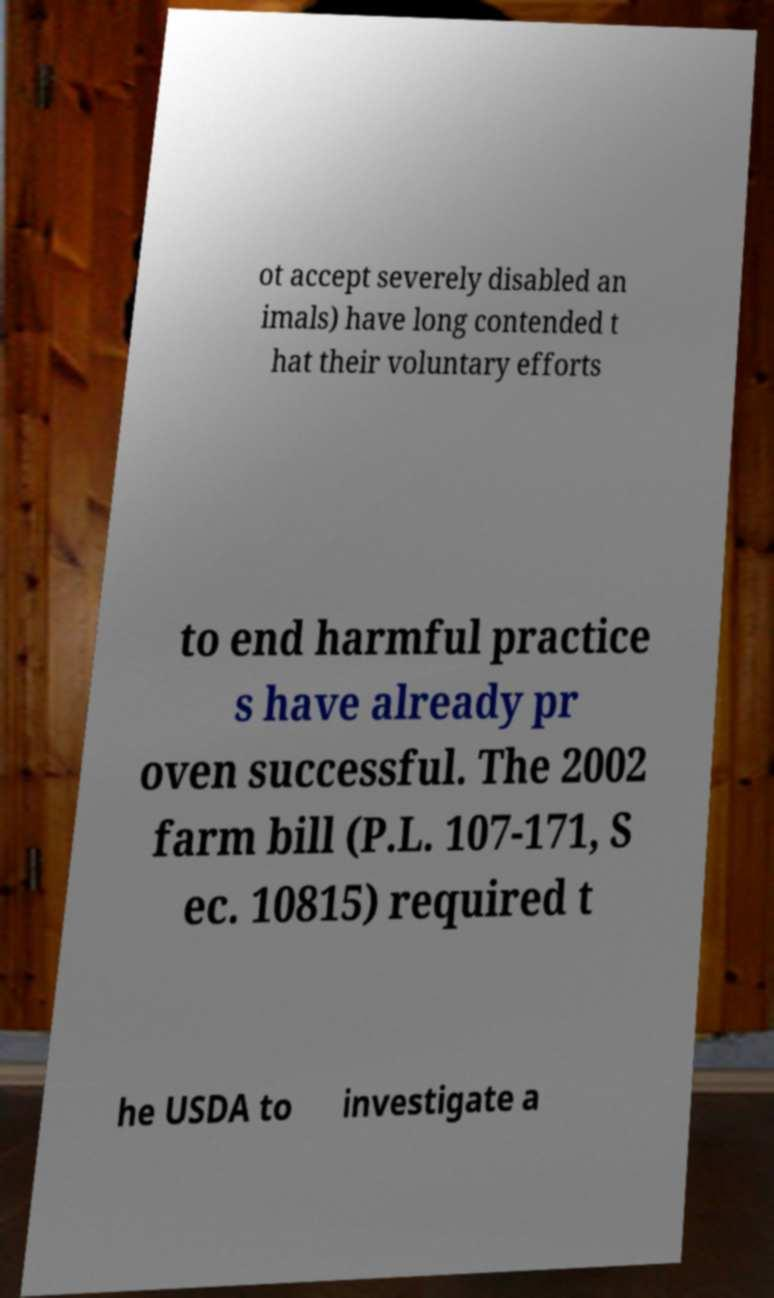For documentation purposes, I need the text within this image transcribed. Could you provide that? ot accept severely disabled an imals) have long contended t hat their voluntary efforts to end harmful practice s have already pr oven successful. The 2002 farm bill (P.L. 107-171, S ec. 10815) required t he USDA to investigate a 